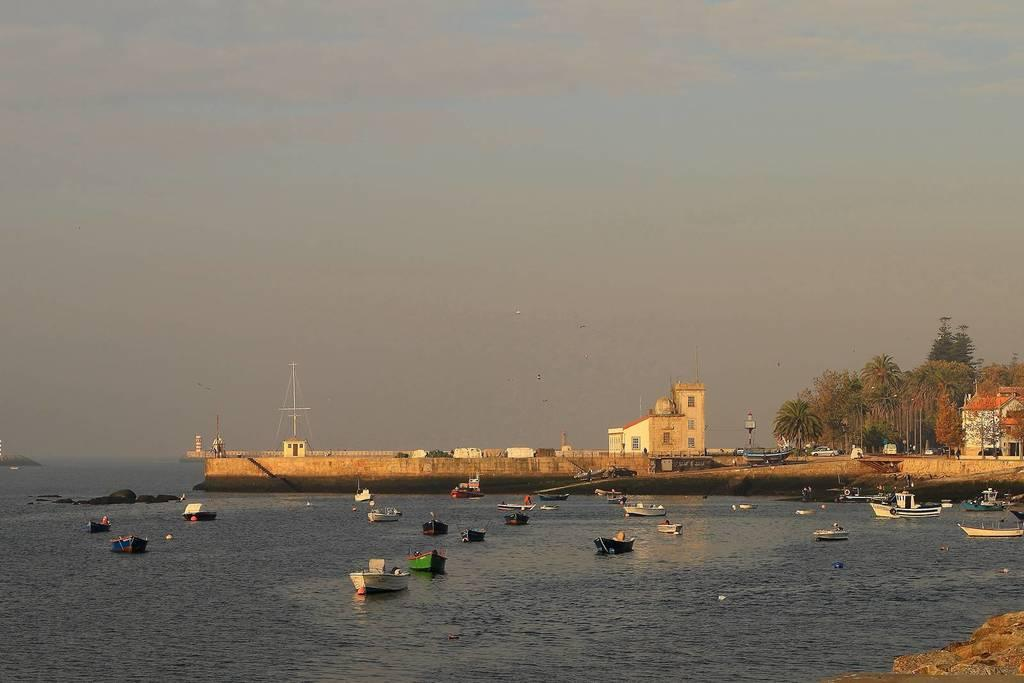What is in the water in the image? There are boats in the water in the image. What can be seen in the background of the image? There are buildings visible in the background of the image. What type of vegetation is present in the image? There are trees present in the image. What is the weight of the chess pieces in the image? There are no chess pieces present in the image, so it is not possible to determine their weight. 